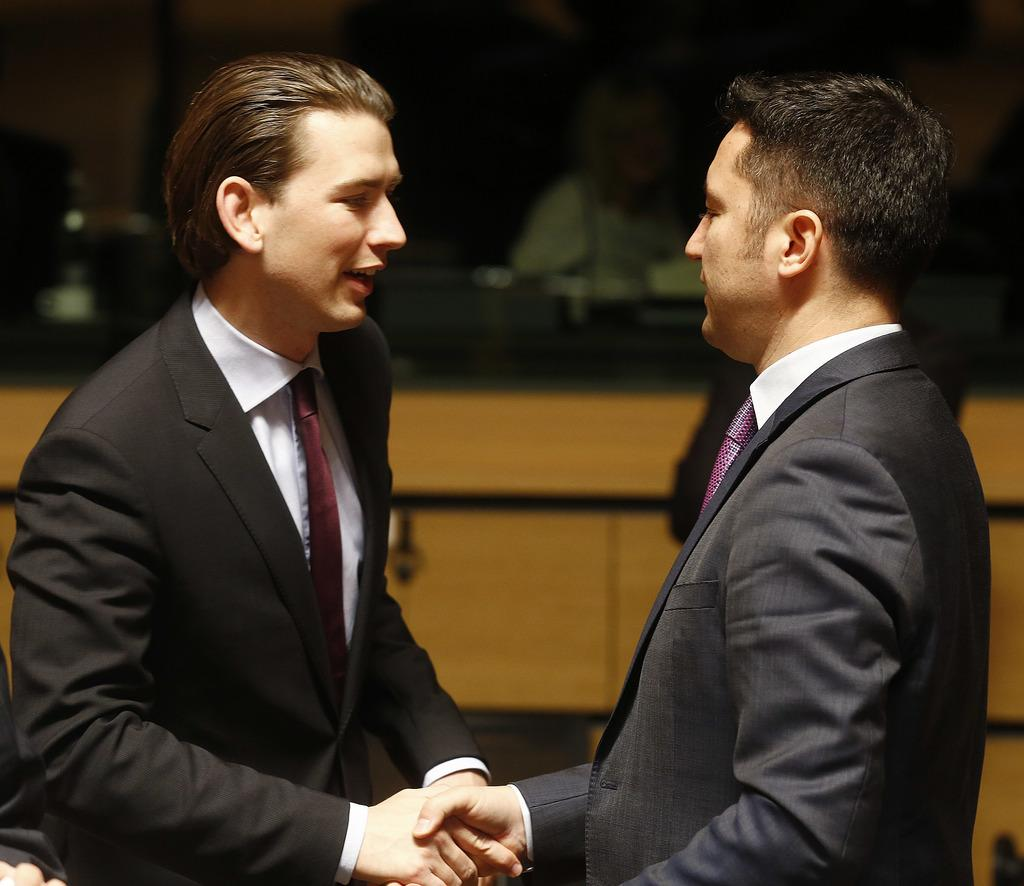How many people are in the image? There are two men in the image. What are the men doing in the image? The men are standing and shaking hands. What type of clothing are the men wearing? The men are wearing blazers, ties, and shirts. What can be seen in the background of the image? There is a wooden plank in the background of the image. Reasoning: Let'g: Let's think step by step in order to produce the conversation. We start by identifying the number of people in the image, which is two men. Then, we describe their actions, noting that they are standing and shaking hands. Next, we focus on their clothing, mentioning that they are wearing blazers, ties, and shirts. Finally, we describe the background, which includes a wooden plank. Absurd Question/Answer: What type of oven can be seen in the image? There is no oven present in the image. What is the seasonal context of the image, considering the presence of spring? The image does not provide any information about the season, and there is no mention of spring. 